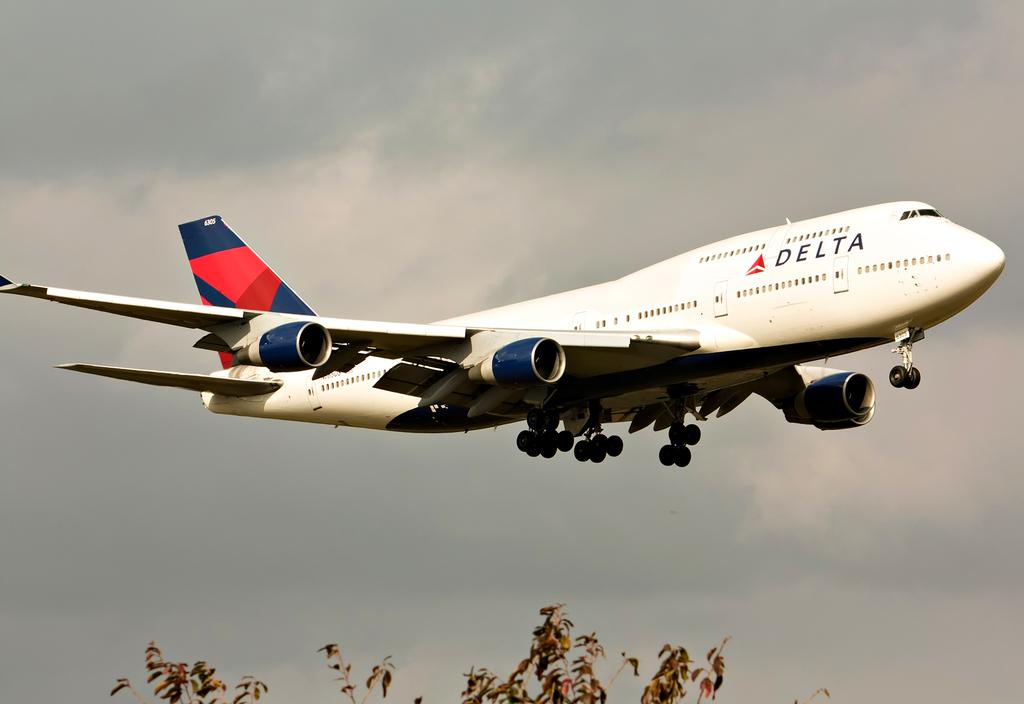What are the numbers on the tail?
Your answer should be compact. 6305. What airline name is printed on the plane?
Ensure brevity in your answer.  Delta. 